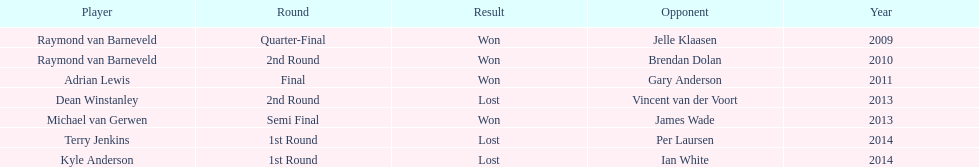Who was the last to win against his opponent? Michael van Gerwen. 